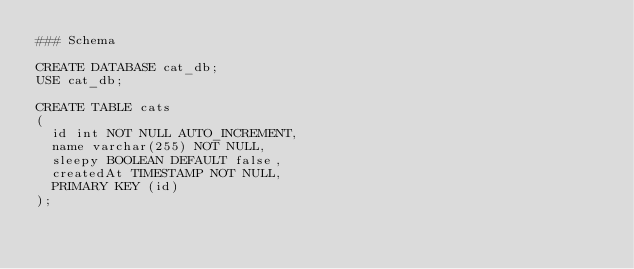<code> <loc_0><loc_0><loc_500><loc_500><_SQL_>### Schema

CREATE DATABASE cat_db;
USE cat_db;

CREATE TABLE cats
(
	id int NOT NULL AUTO_INCREMENT,
	name varchar(255) NOT NULL,
	sleepy BOOLEAN DEFAULT false,
	createdAt TIMESTAMP NOT NULL,
	PRIMARY KEY (id)
);
</code> 